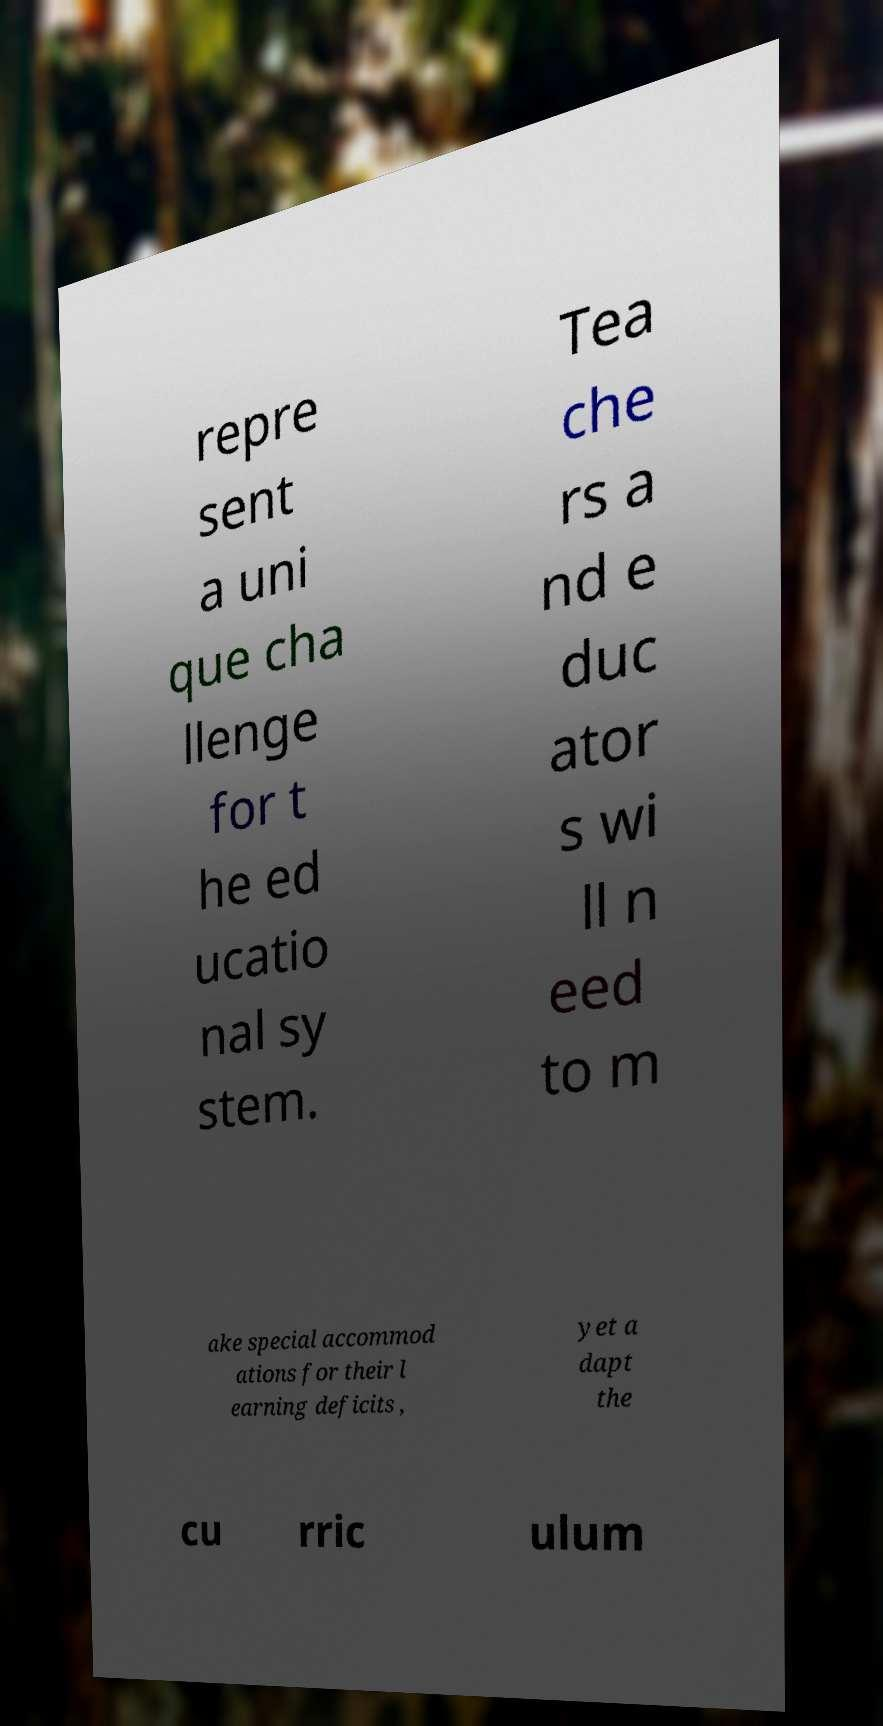Could you assist in decoding the text presented in this image and type it out clearly? repre sent a uni que cha llenge for t he ed ucatio nal sy stem. Tea che rs a nd e duc ator s wi ll n eed to m ake special accommod ations for their l earning deficits , yet a dapt the cu rric ulum 